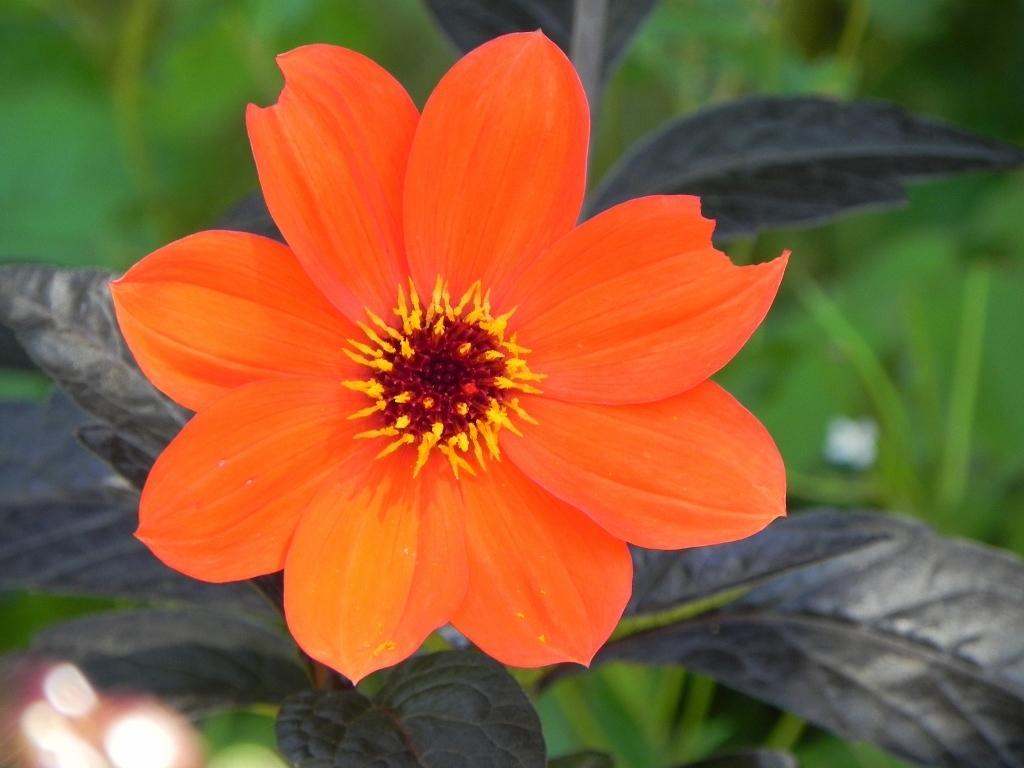Describe this image in one or two sentences. In the image there is an orange flower to a plant. 